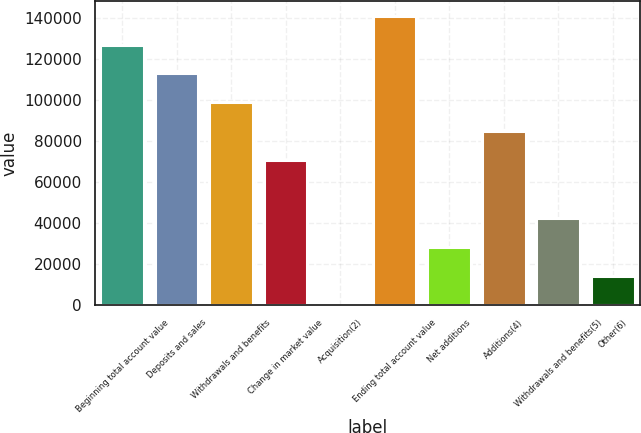Convert chart. <chart><loc_0><loc_0><loc_500><loc_500><bar_chart><fcel>Beginning total account value<fcel>Deposits and sales<fcel>Withdrawals and benefits<fcel>Change in market value<fcel>Acquisition(2)<fcel>Ending total account value<fcel>Net additions<fcel>Additions(4)<fcel>Withdrawals and benefits(5)<fcel>Other(6)<nl><fcel>127182<fcel>113051<fcel>98919.8<fcel>70657.7<fcel>2.31<fcel>141313<fcel>28264.5<fcel>84788.7<fcel>42395.5<fcel>14133.4<nl></chart> 